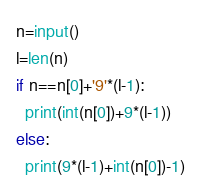<code> <loc_0><loc_0><loc_500><loc_500><_Python_>n=input()
l=len(n)
if n==n[0]+'9'*(l-1):
  print(int(n[0])+9*(l-1))
else:
  print(9*(l-1)+int(n[0])-1)</code> 